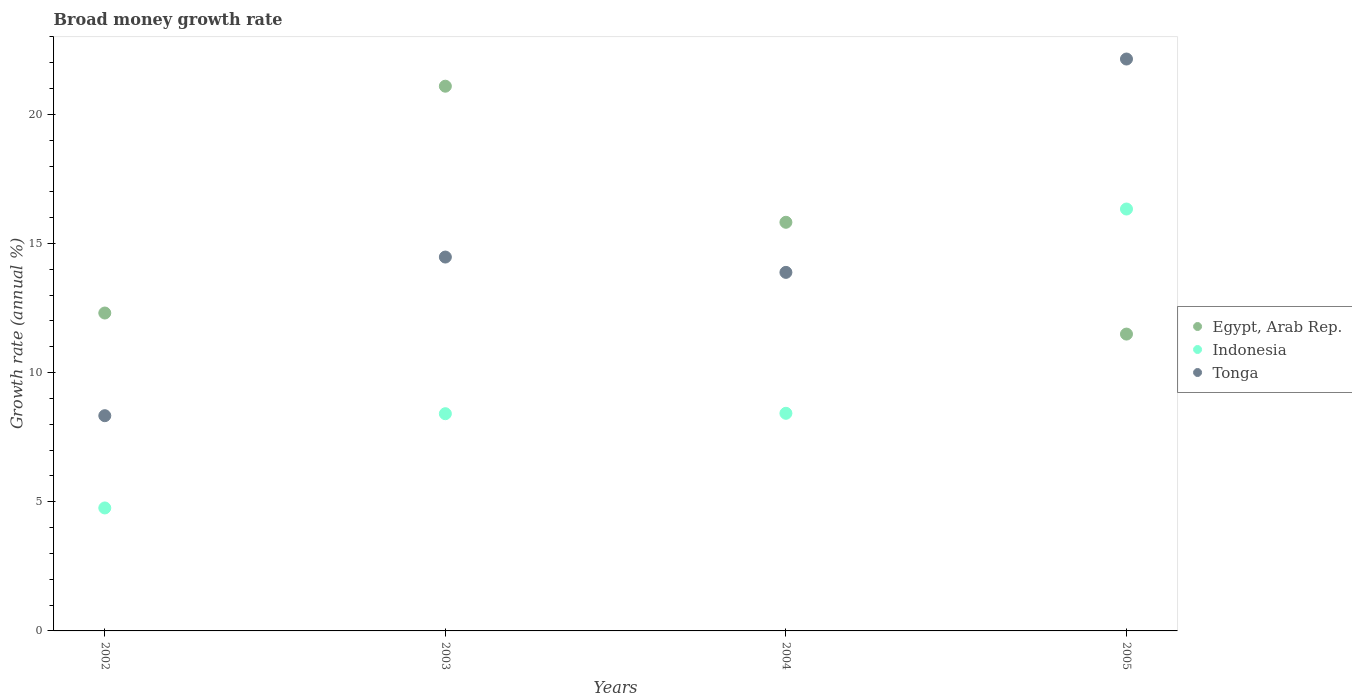How many different coloured dotlines are there?
Your response must be concise. 3. What is the growth rate in Tonga in 2004?
Your response must be concise. 13.88. Across all years, what is the maximum growth rate in Tonga?
Keep it short and to the point. 22.14. Across all years, what is the minimum growth rate in Egypt, Arab Rep.?
Your answer should be very brief. 11.49. In which year was the growth rate in Tonga maximum?
Your answer should be compact. 2005. In which year was the growth rate in Egypt, Arab Rep. minimum?
Offer a terse response. 2005. What is the total growth rate in Indonesia in the graph?
Your answer should be compact. 37.93. What is the difference between the growth rate in Indonesia in 2003 and that in 2005?
Keep it short and to the point. -7.93. What is the difference between the growth rate in Tonga in 2002 and the growth rate in Egypt, Arab Rep. in 2003?
Give a very brief answer. -12.76. What is the average growth rate in Indonesia per year?
Your response must be concise. 9.48. In the year 2002, what is the difference between the growth rate in Indonesia and growth rate in Tonga?
Provide a short and direct response. -3.57. What is the ratio of the growth rate in Tonga in 2002 to that in 2004?
Your answer should be very brief. 0.6. Is the growth rate in Tonga in 2003 less than that in 2004?
Your response must be concise. No. What is the difference between the highest and the second highest growth rate in Indonesia?
Offer a terse response. 7.91. What is the difference between the highest and the lowest growth rate in Tonga?
Keep it short and to the point. 13.81. Is the sum of the growth rate in Indonesia in 2002 and 2005 greater than the maximum growth rate in Tonga across all years?
Your response must be concise. No. Does the growth rate in Egypt, Arab Rep. monotonically increase over the years?
Your answer should be very brief. No. How many dotlines are there?
Keep it short and to the point. 3. How many years are there in the graph?
Your answer should be compact. 4. Does the graph contain any zero values?
Your answer should be very brief. No. What is the title of the graph?
Make the answer very short. Broad money growth rate. Does "Sweden" appear as one of the legend labels in the graph?
Make the answer very short. No. What is the label or title of the Y-axis?
Provide a succinct answer. Growth rate (annual %). What is the Growth rate (annual %) in Egypt, Arab Rep. in 2002?
Provide a short and direct response. 12.31. What is the Growth rate (annual %) in Indonesia in 2002?
Offer a very short reply. 4.76. What is the Growth rate (annual %) of Tonga in 2002?
Offer a terse response. 8.33. What is the Growth rate (annual %) of Egypt, Arab Rep. in 2003?
Make the answer very short. 21.09. What is the Growth rate (annual %) of Indonesia in 2003?
Your answer should be very brief. 8.41. What is the Growth rate (annual %) in Tonga in 2003?
Offer a very short reply. 14.48. What is the Growth rate (annual %) in Egypt, Arab Rep. in 2004?
Make the answer very short. 15.82. What is the Growth rate (annual %) in Indonesia in 2004?
Offer a very short reply. 8.43. What is the Growth rate (annual %) of Tonga in 2004?
Give a very brief answer. 13.88. What is the Growth rate (annual %) of Egypt, Arab Rep. in 2005?
Your answer should be compact. 11.49. What is the Growth rate (annual %) in Indonesia in 2005?
Your answer should be very brief. 16.34. What is the Growth rate (annual %) of Tonga in 2005?
Provide a short and direct response. 22.14. Across all years, what is the maximum Growth rate (annual %) of Egypt, Arab Rep.?
Provide a succinct answer. 21.09. Across all years, what is the maximum Growth rate (annual %) of Indonesia?
Provide a succinct answer. 16.34. Across all years, what is the maximum Growth rate (annual %) in Tonga?
Your answer should be compact. 22.14. Across all years, what is the minimum Growth rate (annual %) of Egypt, Arab Rep.?
Provide a short and direct response. 11.49. Across all years, what is the minimum Growth rate (annual %) in Indonesia?
Provide a short and direct response. 4.76. Across all years, what is the minimum Growth rate (annual %) in Tonga?
Provide a short and direct response. 8.33. What is the total Growth rate (annual %) of Egypt, Arab Rep. in the graph?
Offer a very short reply. 60.71. What is the total Growth rate (annual %) in Indonesia in the graph?
Make the answer very short. 37.93. What is the total Growth rate (annual %) of Tonga in the graph?
Offer a terse response. 58.83. What is the difference between the Growth rate (annual %) in Egypt, Arab Rep. in 2002 and that in 2003?
Your response must be concise. -8.78. What is the difference between the Growth rate (annual %) of Indonesia in 2002 and that in 2003?
Give a very brief answer. -3.65. What is the difference between the Growth rate (annual %) in Tonga in 2002 and that in 2003?
Keep it short and to the point. -6.14. What is the difference between the Growth rate (annual %) of Egypt, Arab Rep. in 2002 and that in 2004?
Your response must be concise. -3.51. What is the difference between the Growth rate (annual %) in Indonesia in 2002 and that in 2004?
Your answer should be very brief. -3.66. What is the difference between the Growth rate (annual %) of Tonga in 2002 and that in 2004?
Your answer should be very brief. -5.55. What is the difference between the Growth rate (annual %) of Egypt, Arab Rep. in 2002 and that in 2005?
Your answer should be compact. 0.82. What is the difference between the Growth rate (annual %) in Indonesia in 2002 and that in 2005?
Give a very brief answer. -11.57. What is the difference between the Growth rate (annual %) of Tonga in 2002 and that in 2005?
Offer a very short reply. -13.81. What is the difference between the Growth rate (annual %) of Egypt, Arab Rep. in 2003 and that in 2004?
Ensure brevity in your answer.  5.27. What is the difference between the Growth rate (annual %) in Indonesia in 2003 and that in 2004?
Provide a succinct answer. -0.02. What is the difference between the Growth rate (annual %) of Tonga in 2003 and that in 2004?
Make the answer very short. 0.59. What is the difference between the Growth rate (annual %) in Egypt, Arab Rep. in 2003 and that in 2005?
Your response must be concise. 9.6. What is the difference between the Growth rate (annual %) of Indonesia in 2003 and that in 2005?
Offer a terse response. -7.93. What is the difference between the Growth rate (annual %) in Tonga in 2003 and that in 2005?
Keep it short and to the point. -7.67. What is the difference between the Growth rate (annual %) of Egypt, Arab Rep. in 2004 and that in 2005?
Your response must be concise. 4.33. What is the difference between the Growth rate (annual %) of Indonesia in 2004 and that in 2005?
Provide a succinct answer. -7.91. What is the difference between the Growth rate (annual %) in Tonga in 2004 and that in 2005?
Your answer should be compact. -8.26. What is the difference between the Growth rate (annual %) in Egypt, Arab Rep. in 2002 and the Growth rate (annual %) in Indonesia in 2003?
Keep it short and to the point. 3.9. What is the difference between the Growth rate (annual %) of Egypt, Arab Rep. in 2002 and the Growth rate (annual %) of Tonga in 2003?
Provide a short and direct response. -2.17. What is the difference between the Growth rate (annual %) of Indonesia in 2002 and the Growth rate (annual %) of Tonga in 2003?
Offer a terse response. -9.71. What is the difference between the Growth rate (annual %) in Egypt, Arab Rep. in 2002 and the Growth rate (annual %) in Indonesia in 2004?
Your answer should be compact. 3.88. What is the difference between the Growth rate (annual %) of Egypt, Arab Rep. in 2002 and the Growth rate (annual %) of Tonga in 2004?
Ensure brevity in your answer.  -1.57. What is the difference between the Growth rate (annual %) of Indonesia in 2002 and the Growth rate (annual %) of Tonga in 2004?
Provide a short and direct response. -9.12. What is the difference between the Growth rate (annual %) of Egypt, Arab Rep. in 2002 and the Growth rate (annual %) of Indonesia in 2005?
Your answer should be compact. -4.03. What is the difference between the Growth rate (annual %) of Egypt, Arab Rep. in 2002 and the Growth rate (annual %) of Tonga in 2005?
Offer a terse response. -9.83. What is the difference between the Growth rate (annual %) in Indonesia in 2002 and the Growth rate (annual %) in Tonga in 2005?
Keep it short and to the point. -17.38. What is the difference between the Growth rate (annual %) in Egypt, Arab Rep. in 2003 and the Growth rate (annual %) in Indonesia in 2004?
Provide a short and direct response. 12.66. What is the difference between the Growth rate (annual %) of Egypt, Arab Rep. in 2003 and the Growth rate (annual %) of Tonga in 2004?
Give a very brief answer. 7.21. What is the difference between the Growth rate (annual %) of Indonesia in 2003 and the Growth rate (annual %) of Tonga in 2004?
Offer a very short reply. -5.47. What is the difference between the Growth rate (annual %) of Egypt, Arab Rep. in 2003 and the Growth rate (annual %) of Indonesia in 2005?
Your answer should be very brief. 4.76. What is the difference between the Growth rate (annual %) of Egypt, Arab Rep. in 2003 and the Growth rate (annual %) of Tonga in 2005?
Ensure brevity in your answer.  -1.05. What is the difference between the Growth rate (annual %) in Indonesia in 2003 and the Growth rate (annual %) in Tonga in 2005?
Offer a very short reply. -13.73. What is the difference between the Growth rate (annual %) of Egypt, Arab Rep. in 2004 and the Growth rate (annual %) of Indonesia in 2005?
Make the answer very short. -0.51. What is the difference between the Growth rate (annual %) in Egypt, Arab Rep. in 2004 and the Growth rate (annual %) in Tonga in 2005?
Give a very brief answer. -6.32. What is the difference between the Growth rate (annual %) in Indonesia in 2004 and the Growth rate (annual %) in Tonga in 2005?
Give a very brief answer. -13.72. What is the average Growth rate (annual %) of Egypt, Arab Rep. per year?
Provide a short and direct response. 15.18. What is the average Growth rate (annual %) of Indonesia per year?
Offer a terse response. 9.48. What is the average Growth rate (annual %) of Tonga per year?
Offer a very short reply. 14.71. In the year 2002, what is the difference between the Growth rate (annual %) in Egypt, Arab Rep. and Growth rate (annual %) in Indonesia?
Your answer should be compact. 7.55. In the year 2002, what is the difference between the Growth rate (annual %) in Egypt, Arab Rep. and Growth rate (annual %) in Tonga?
Ensure brevity in your answer.  3.98. In the year 2002, what is the difference between the Growth rate (annual %) of Indonesia and Growth rate (annual %) of Tonga?
Ensure brevity in your answer.  -3.57. In the year 2003, what is the difference between the Growth rate (annual %) in Egypt, Arab Rep. and Growth rate (annual %) in Indonesia?
Offer a terse response. 12.68. In the year 2003, what is the difference between the Growth rate (annual %) of Egypt, Arab Rep. and Growth rate (annual %) of Tonga?
Give a very brief answer. 6.62. In the year 2003, what is the difference between the Growth rate (annual %) in Indonesia and Growth rate (annual %) in Tonga?
Ensure brevity in your answer.  -6.07. In the year 2004, what is the difference between the Growth rate (annual %) in Egypt, Arab Rep. and Growth rate (annual %) in Indonesia?
Provide a succinct answer. 7.4. In the year 2004, what is the difference between the Growth rate (annual %) of Egypt, Arab Rep. and Growth rate (annual %) of Tonga?
Your answer should be very brief. 1.94. In the year 2004, what is the difference between the Growth rate (annual %) in Indonesia and Growth rate (annual %) in Tonga?
Ensure brevity in your answer.  -5.46. In the year 2005, what is the difference between the Growth rate (annual %) in Egypt, Arab Rep. and Growth rate (annual %) in Indonesia?
Your response must be concise. -4.84. In the year 2005, what is the difference between the Growth rate (annual %) in Egypt, Arab Rep. and Growth rate (annual %) in Tonga?
Provide a short and direct response. -10.65. In the year 2005, what is the difference between the Growth rate (annual %) in Indonesia and Growth rate (annual %) in Tonga?
Offer a very short reply. -5.81. What is the ratio of the Growth rate (annual %) in Egypt, Arab Rep. in 2002 to that in 2003?
Your response must be concise. 0.58. What is the ratio of the Growth rate (annual %) of Indonesia in 2002 to that in 2003?
Provide a short and direct response. 0.57. What is the ratio of the Growth rate (annual %) of Tonga in 2002 to that in 2003?
Provide a succinct answer. 0.58. What is the ratio of the Growth rate (annual %) of Egypt, Arab Rep. in 2002 to that in 2004?
Provide a short and direct response. 0.78. What is the ratio of the Growth rate (annual %) in Indonesia in 2002 to that in 2004?
Keep it short and to the point. 0.57. What is the ratio of the Growth rate (annual %) of Tonga in 2002 to that in 2004?
Your answer should be very brief. 0.6. What is the ratio of the Growth rate (annual %) in Egypt, Arab Rep. in 2002 to that in 2005?
Give a very brief answer. 1.07. What is the ratio of the Growth rate (annual %) of Indonesia in 2002 to that in 2005?
Your answer should be compact. 0.29. What is the ratio of the Growth rate (annual %) in Tonga in 2002 to that in 2005?
Your answer should be very brief. 0.38. What is the ratio of the Growth rate (annual %) of Egypt, Arab Rep. in 2003 to that in 2004?
Offer a very short reply. 1.33. What is the ratio of the Growth rate (annual %) of Tonga in 2003 to that in 2004?
Give a very brief answer. 1.04. What is the ratio of the Growth rate (annual %) of Egypt, Arab Rep. in 2003 to that in 2005?
Your answer should be compact. 1.83. What is the ratio of the Growth rate (annual %) of Indonesia in 2003 to that in 2005?
Your answer should be very brief. 0.51. What is the ratio of the Growth rate (annual %) of Tonga in 2003 to that in 2005?
Provide a succinct answer. 0.65. What is the ratio of the Growth rate (annual %) in Egypt, Arab Rep. in 2004 to that in 2005?
Ensure brevity in your answer.  1.38. What is the ratio of the Growth rate (annual %) of Indonesia in 2004 to that in 2005?
Your answer should be compact. 0.52. What is the ratio of the Growth rate (annual %) in Tonga in 2004 to that in 2005?
Provide a short and direct response. 0.63. What is the difference between the highest and the second highest Growth rate (annual %) in Egypt, Arab Rep.?
Your answer should be very brief. 5.27. What is the difference between the highest and the second highest Growth rate (annual %) in Indonesia?
Offer a terse response. 7.91. What is the difference between the highest and the second highest Growth rate (annual %) in Tonga?
Your response must be concise. 7.67. What is the difference between the highest and the lowest Growth rate (annual %) in Egypt, Arab Rep.?
Provide a short and direct response. 9.6. What is the difference between the highest and the lowest Growth rate (annual %) in Indonesia?
Your response must be concise. 11.57. What is the difference between the highest and the lowest Growth rate (annual %) in Tonga?
Give a very brief answer. 13.81. 